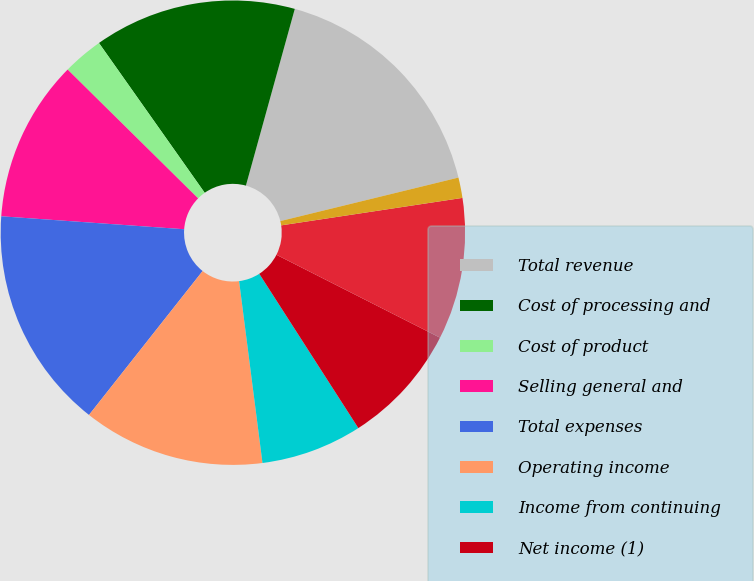<chart> <loc_0><loc_0><loc_500><loc_500><pie_chart><fcel>Total revenue<fcel>Cost of processing and<fcel>Cost of product<fcel>Selling general and<fcel>Total expenses<fcel>Operating income<fcel>Income from continuing<fcel>Net income (1)<fcel>Comprehensive income<fcel>Basic<nl><fcel>16.89%<fcel>14.08%<fcel>2.82%<fcel>11.27%<fcel>15.49%<fcel>12.67%<fcel>7.05%<fcel>8.45%<fcel>9.86%<fcel>1.42%<nl></chart> 